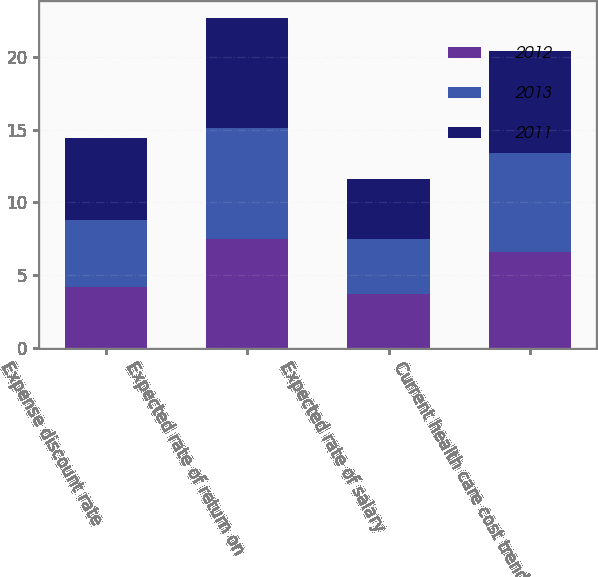Convert chart. <chart><loc_0><loc_0><loc_500><loc_500><stacked_bar_chart><ecel><fcel>Expense discount rate<fcel>Expected rate of return on<fcel>Expected rate of salary<fcel>Current health care cost trend<nl><fcel>2012<fcel>4.2<fcel>7.5<fcel>3.7<fcel>6.6<nl><fcel>2013<fcel>4.6<fcel>7.6<fcel>3.8<fcel>6.8<nl><fcel>2011<fcel>5.6<fcel>7.6<fcel>4.1<fcel>7<nl></chart> 